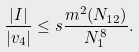Convert formula to latex. <formula><loc_0><loc_0><loc_500><loc_500>\frac { | I | } { | v _ { 4 } | } \leq s \frac { m ^ { 2 } ( N _ { 1 2 } ) } { N _ { 1 } ^ { 8 } } .</formula> 